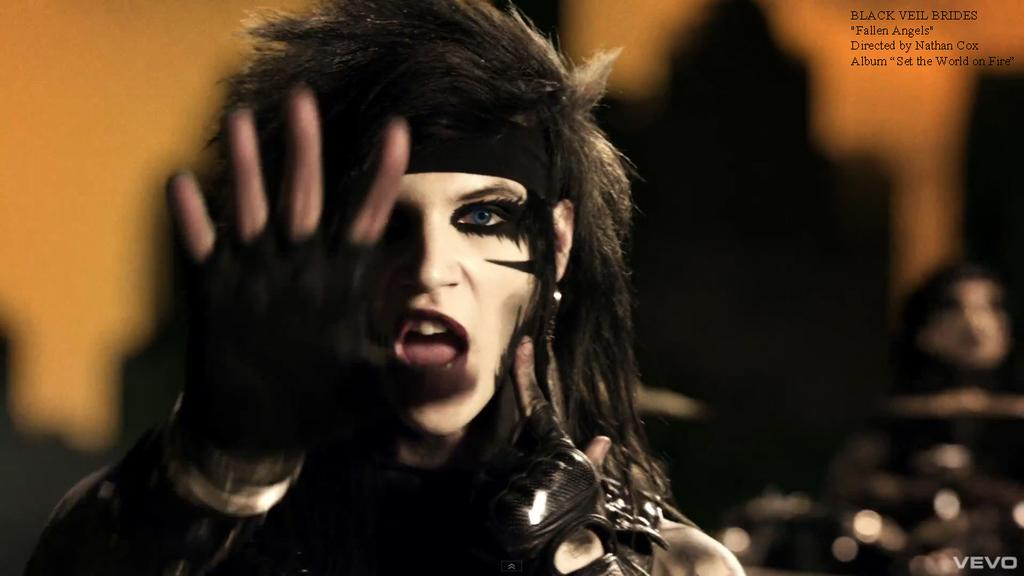Who or what is the main subject in the image? There is a person in the image. What is the person wearing? The person is wearing a black dress and black gloves. Can you describe the background of the image? The background of the image is blurred. What type of trouble is the person experiencing in the image? There is no indication of trouble in the image; the person is simply wearing a black dress and gloves with a blurred background. 